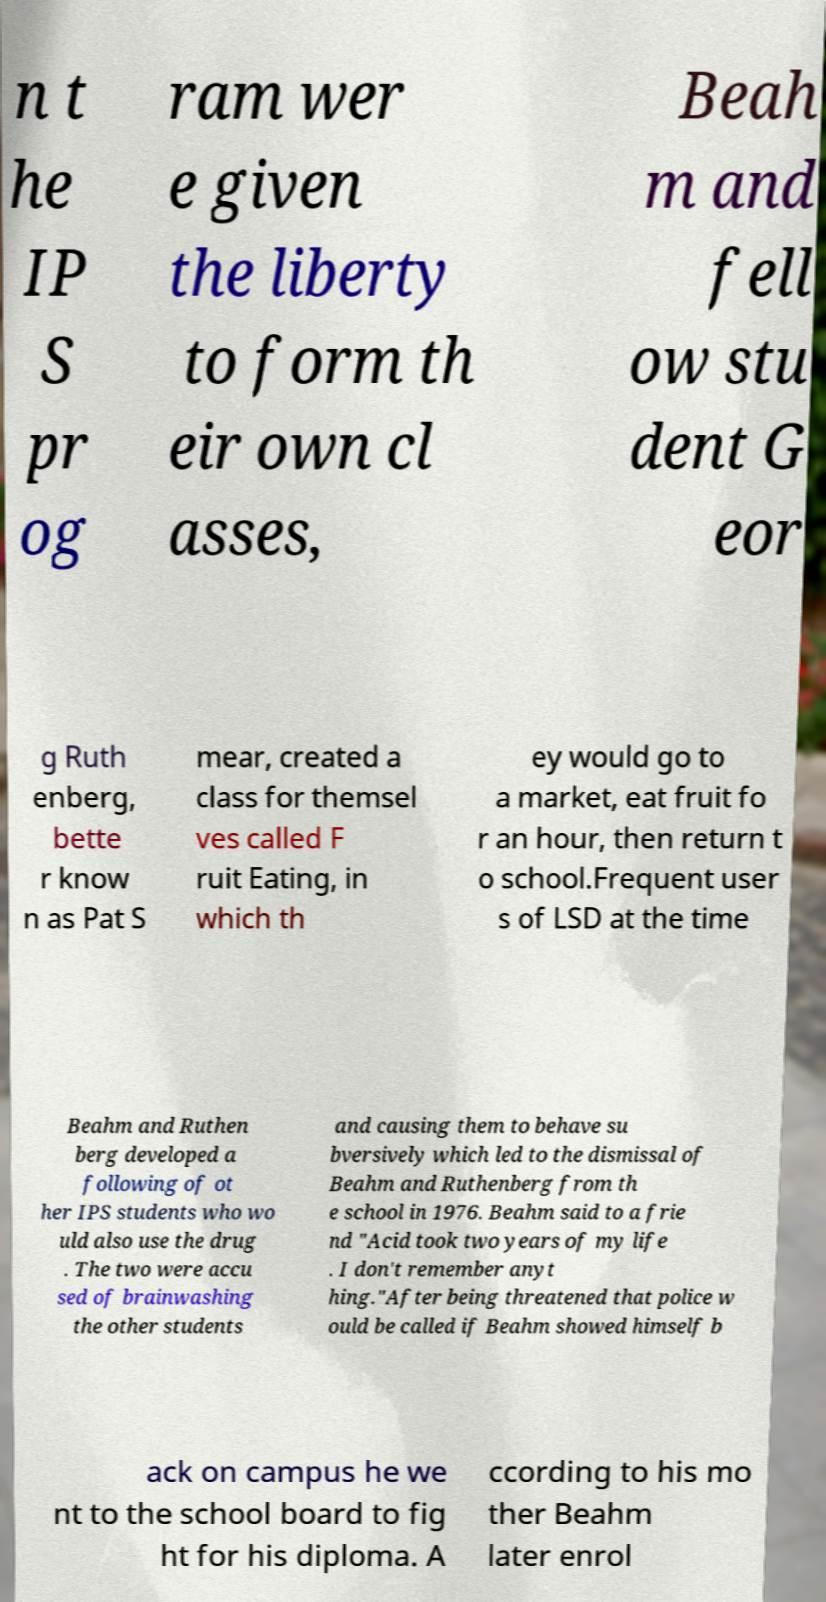Could you extract and type out the text from this image? n t he IP S pr og ram wer e given the liberty to form th eir own cl asses, Beah m and fell ow stu dent G eor g Ruth enberg, bette r know n as Pat S mear, created a class for themsel ves called F ruit Eating, in which th ey would go to a market, eat fruit fo r an hour, then return t o school.Frequent user s of LSD at the time Beahm and Ruthen berg developed a following of ot her IPS students who wo uld also use the drug . The two were accu sed of brainwashing the other students and causing them to behave su bversively which led to the dismissal of Beahm and Ruthenberg from th e school in 1976. Beahm said to a frie nd "Acid took two years of my life . I don't remember anyt hing."After being threatened that police w ould be called if Beahm showed himself b ack on campus he we nt to the school board to fig ht for his diploma. A ccording to his mo ther Beahm later enrol 